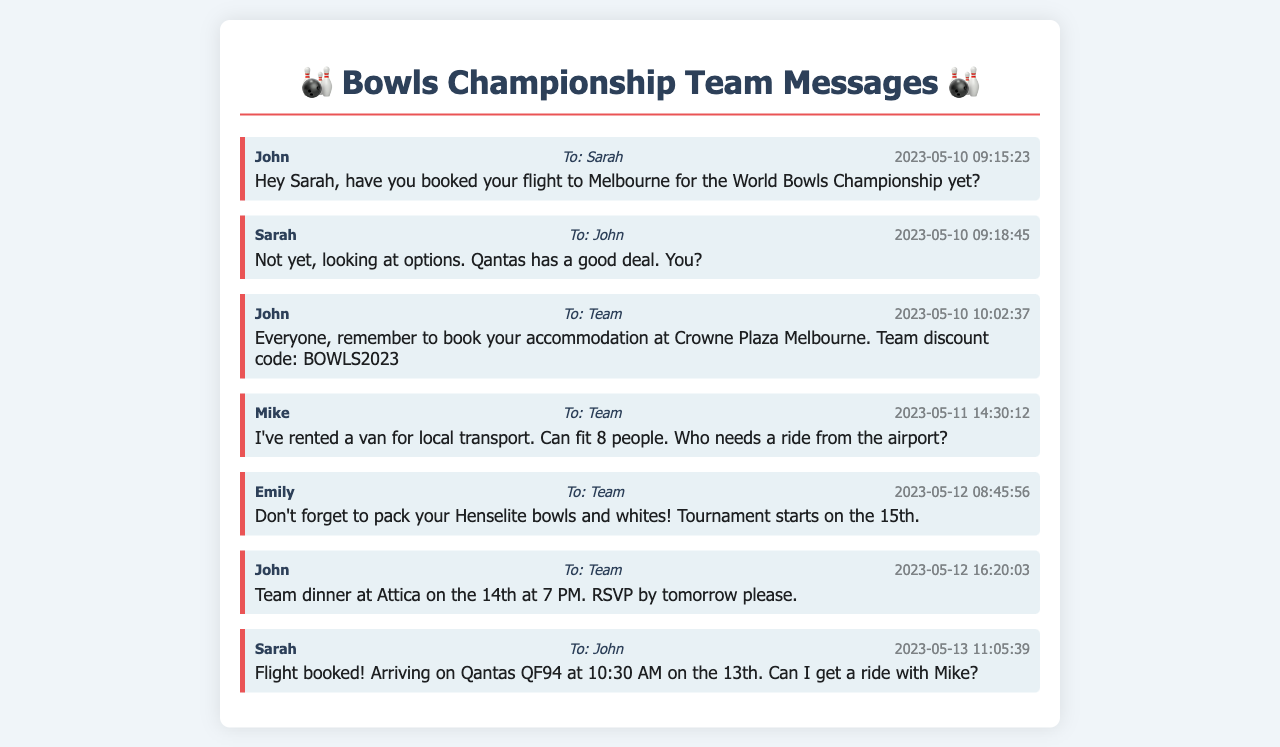What date did John ask Sarah about her flight? John inquired about Sarah's flight on May 10, 2023.
Answer: May 10, 2023 What is the team discount code for accommodation? The document specifies the discount code for the Crowne Plaza Melbourne accommodation.
Answer: BOWLS2023 Who rented a van for local transport? Mike organized the van for local transport and asked who needed a ride.
Answer: Mike When does the tournament start? Emily reminded the team that the tournament starts on the 15th.
Answer: 15th What time is the team dinner at Attica? John scheduled the dinner at 7 PM on the 14th.
Answer: 7 PM How many people can the rented van fit? Mike mentioned that the van can accommodate a certain number of people.
Answer: 8 people What is the flight arrival time for Sarah's flight? Sarah's flight arrives at 10:30 AM on the 13th.
Answer: 10:30 AM What message did Emily send to the team? Emily reminded everyone to pack their specific equipment for the tournament.
Answer: Don't forget to pack your Henselite bowls and whites! Who is Sarah asking for a ride with? Sarah requested a ride with Mike upon her arrival.
Answer: Mike 